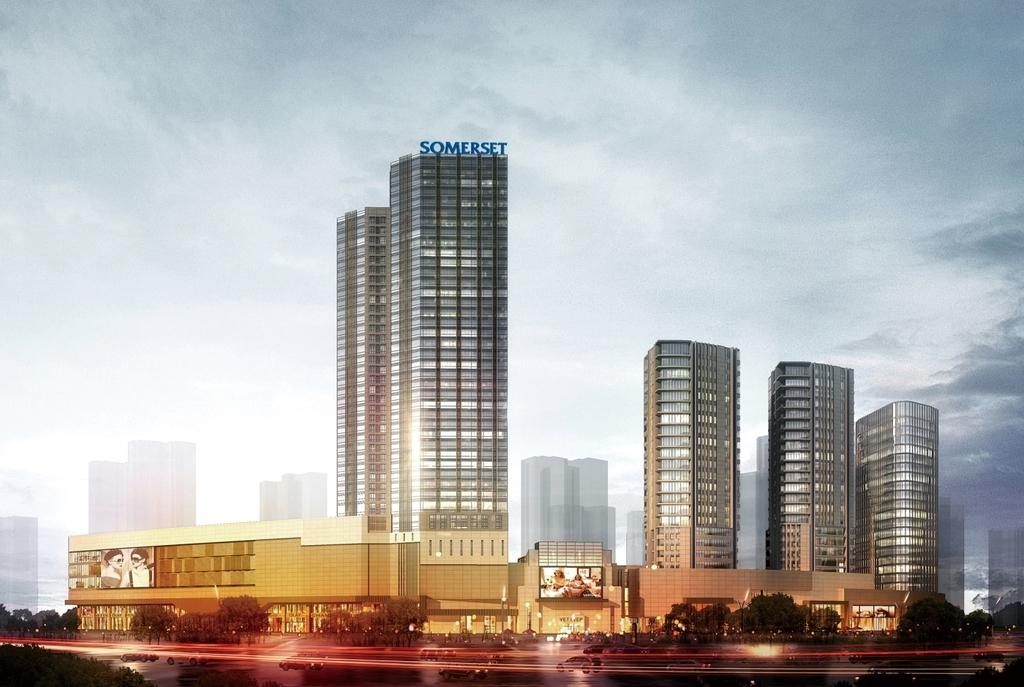What type of structures can be seen in the image? There are buildings in the image. What type of establishments are present in the image? There are shops in the image. What type of vegetation is visible in the image? There are trees in the image. What type of transportation infrastructure is present in the image? There is a road in the image. What is happening on the road in the image? Vehicles are moving on the road. What is visible at the top of the image? The sky is clear and visible at the top of the image. How many fingers can be seen holding the kittens in the image? There are no kittens or fingers present in the image. What is the title of the image? The image does not have a title. 